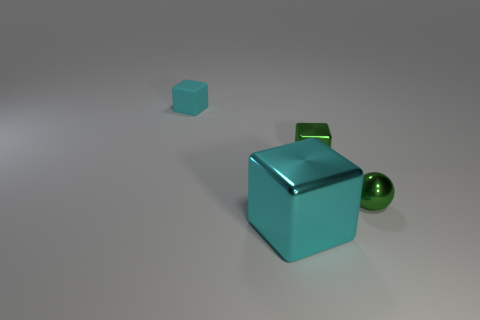Subtract all green metallic blocks. How many blocks are left? 2 Subtract all cyan cylinders. How many cyan cubes are left? 2 Add 1 big blue metal cylinders. How many objects exist? 5 Subtract all green cubes. How many cubes are left? 2 Subtract all cubes. How many objects are left? 1 Subtract 0 green cylinders. How many objects are left? 4 Subtract all cyan blocks. Subtract all red cylinders. How many blocks are left? 1 Subtract all tiny purple rubber cylinders. Subtract all big cyan blocks. How many objects are left? 3 Add 3 cyan shiny objects. How many cyan shiny objects are left? 4 Add 2 tiny spheres. How many tiny spheres exist? 3 